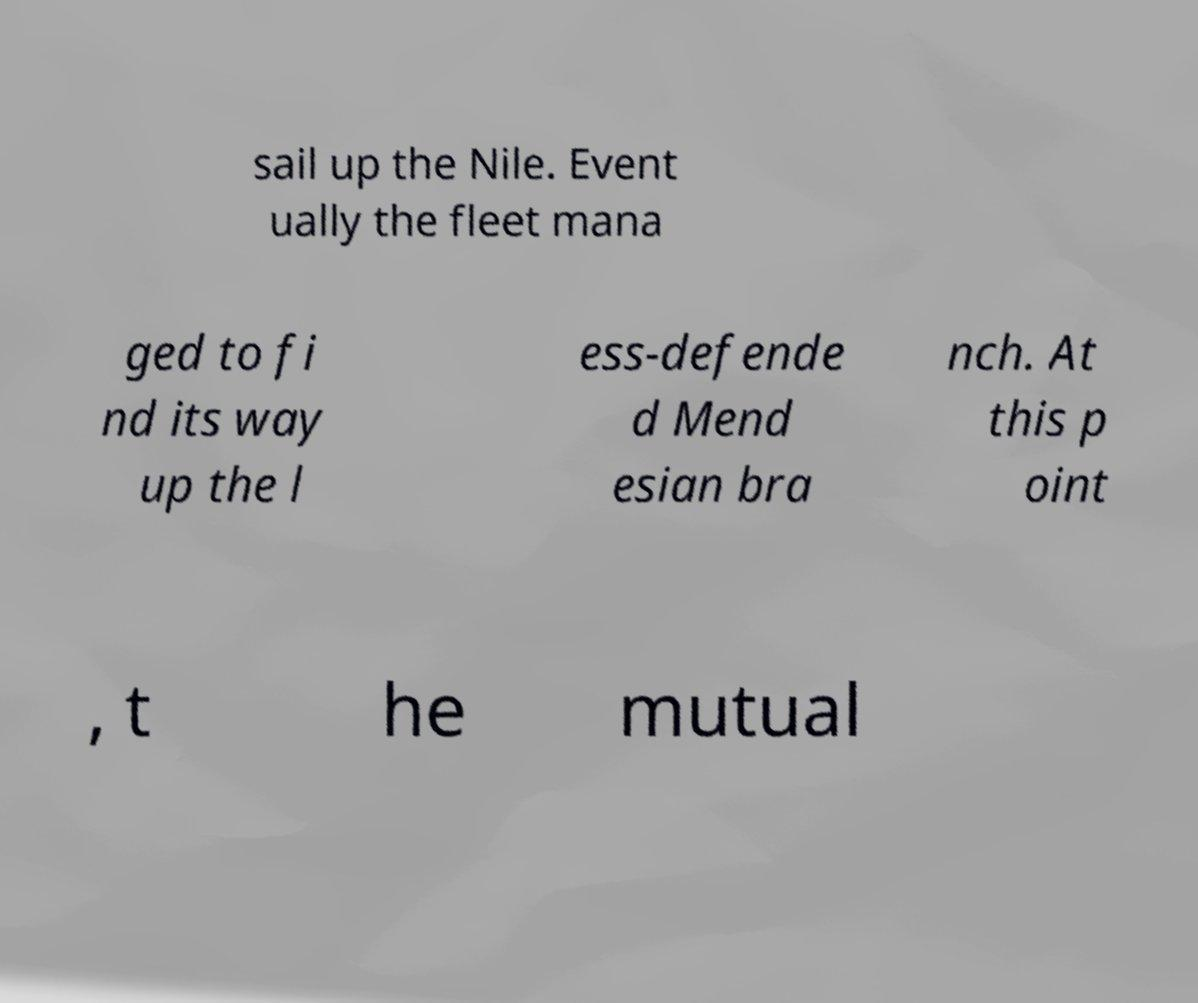There's text embedded in this image that I need extracted. Can you transcribe it verbatim? sail up the Nile. Event ually the fleet mana ged to fi nd its way up the l ess-defende d Mend esian bra nch. At this p oint , t he mutual 